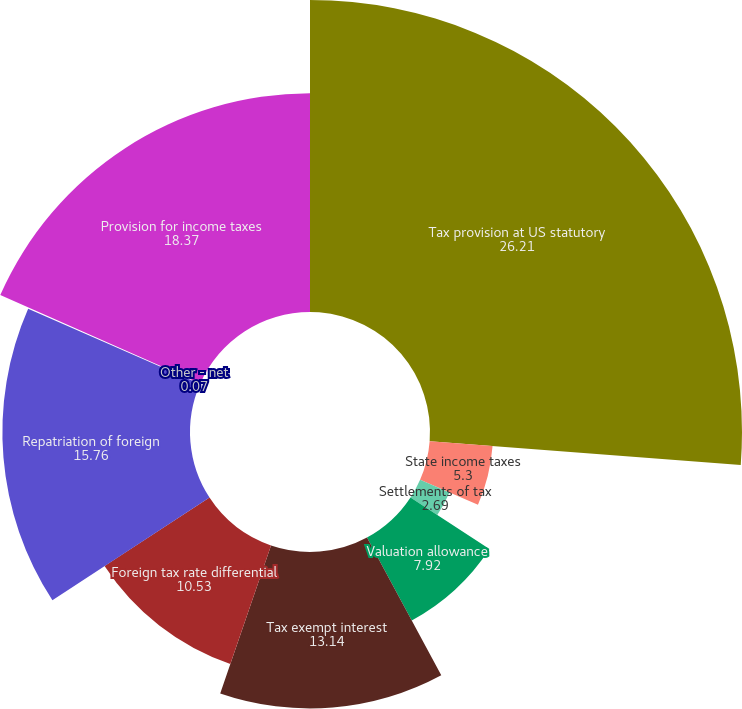Convert chart. <chart><loc_0><loc_0><loc_500><loc_500><pie_chart><fcel>Tax provision at US statutory<fcel>State income taxes<fcel>Settlements of tax<fcel>Valuation allowance<fcel>Tax exempt interest<fcel>Foreign tax rate differential<fcel>Repatriation of foreign<fcel>Other - net<fcel>Provision for income taxes<nl><fcel>26.21%<fcel>5.3%<fcel>2.69%<fcel>7.92%<fcel>13.14%<fcel>10.53%<fcel>15.76%<fcel>0.07%<fcel>18.37%<nl></chart> 